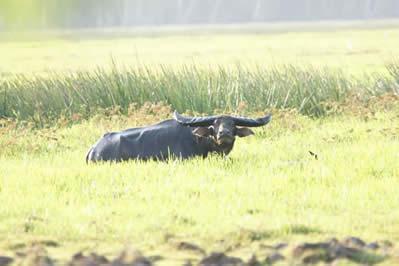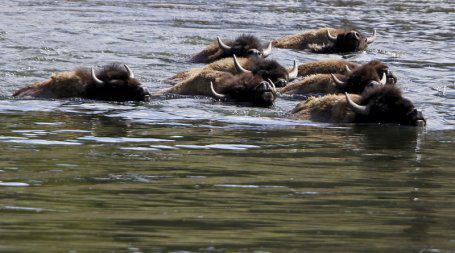The first image is the image on the left, the second image is the image on the right. Evaluate the accuracy of this statement regarding the images: "A cow in the image on the left is walking through the water.". Is it true? Answer yes or no. No. The first image is the image on the left, the second image is the image on the right. For the images shown, is this caption "In at least one image there is only a single bull up to its chest in water." true? Answer yes or no. No. 